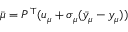Convert formula to latex. <formula><loc_0><loc_0><loc_500><loc_500>\bar { \mu } = P ^ { \top } ( u _ { \mu } + \sigma _ { \mu } ( \bar { y } _ { \mu } - y _ { \mu } ) )</formula> 